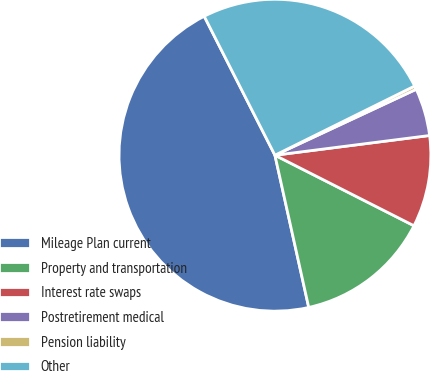<chart> <loc_0><loc_0><loc_500><loc_500><pie_chart><fcel>Mileage Plan current<fcel>Property and transportation<fcel>Interest rate swaps<fcel>Postretirement medical<fcel>Pension liability<fcel>Other<nl><fcel>45.98%<fcel>14.05%<fcel>9.49%<fcel>4.93%<fcel>0.37%<fcel>25.17%<nl></chart> 